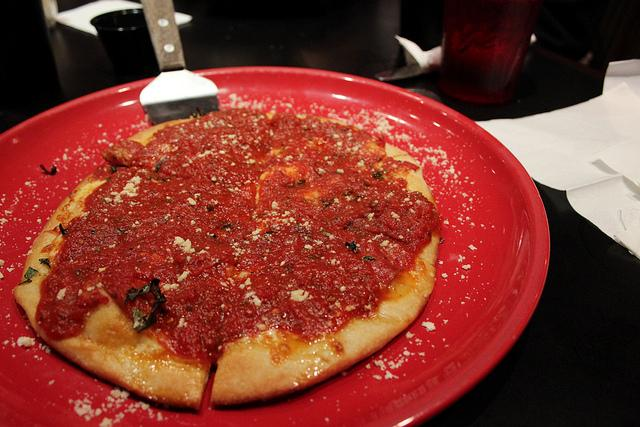What is there an excessive amount of relative to most pizzas?

Choices:
A) bread
B) sauce
C) meat
D) vegetables sauce 